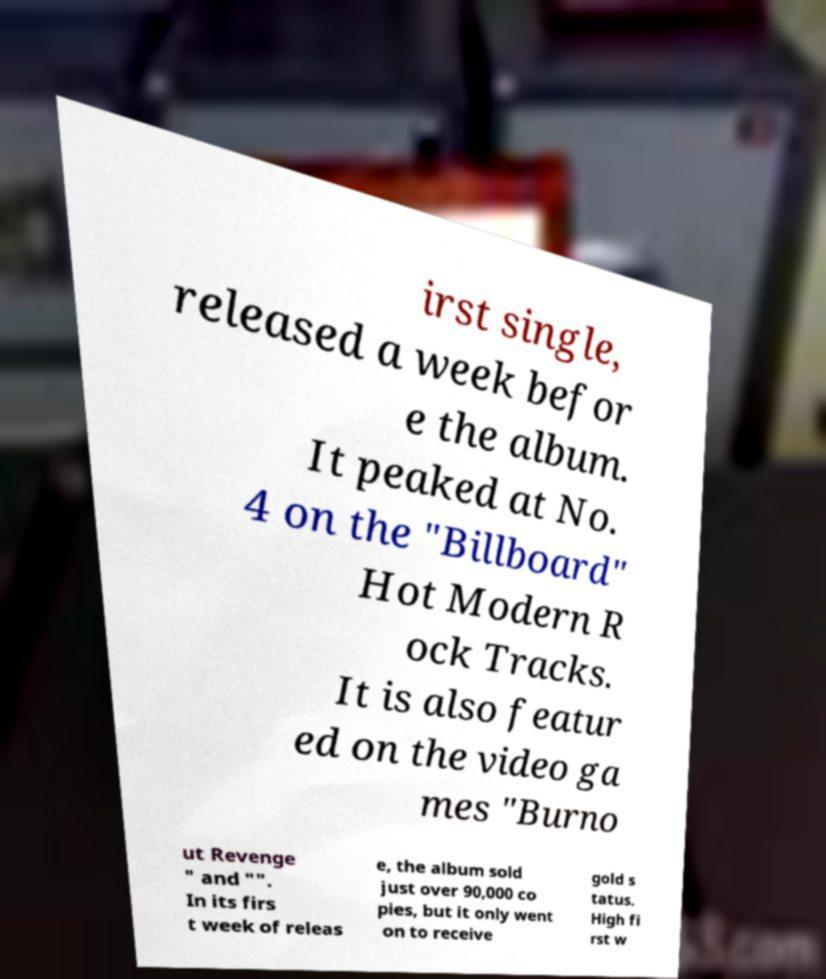I need the written content from this picture converted into text. Can you do that? irst single, released a week befor e the album. It peaked at No. 4 on the "Billboard" Hot Modern R ock Tracks. It is also featur ed on the video ga mes "Burno ut Revenge " and "". In its firs t week of releas e, the album sold just over 90,000 co pies, but it only went on to receive gold s tatus. High fi rst w 